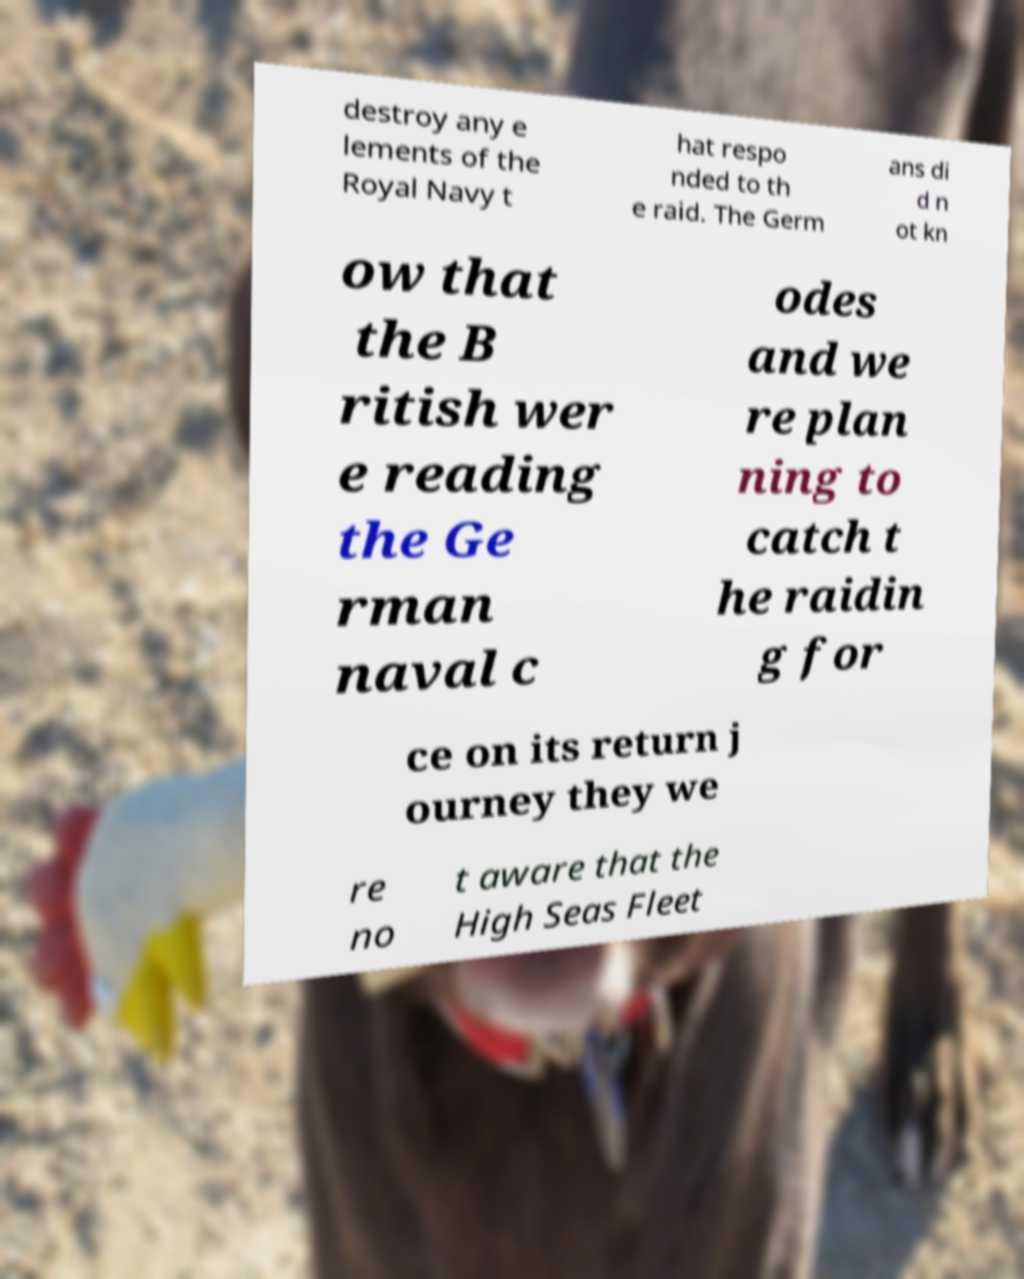Please read and relay the text visible in this image. What does it say? destroy any e lements of the Royal Navy t hat respo nded to th e raid. The Germ ans di d n ot kn ow that the B ritish wer e reading the Ge rman naval c odes and we re plan ning to catch t he raidin g for ce on its return j ourney they we re no t aware that the High Seas Fleet 